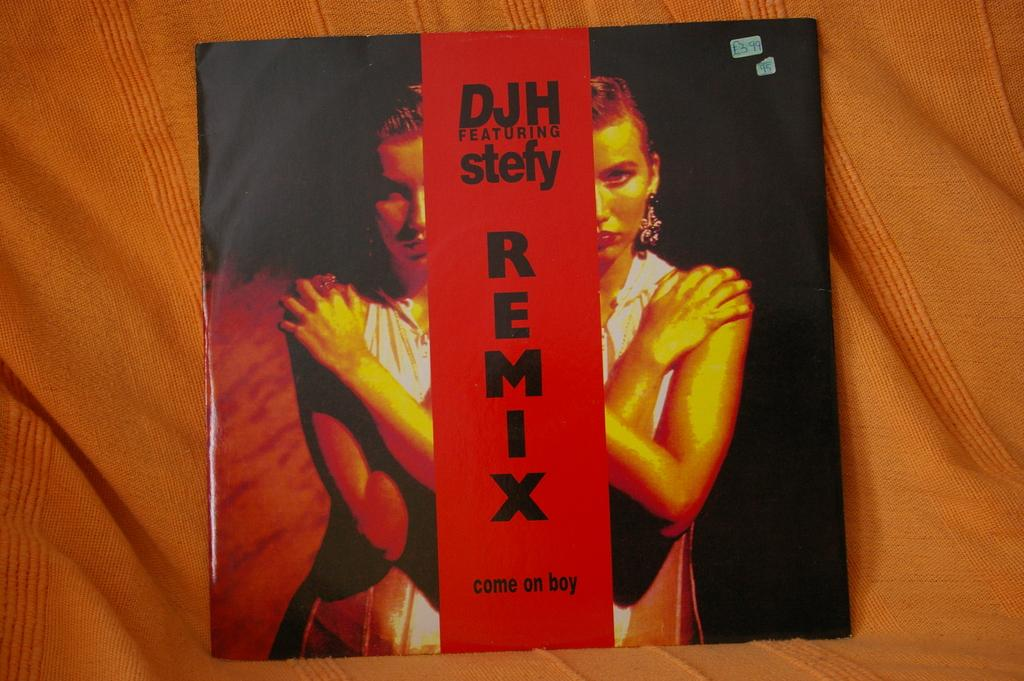<image>
Share a concise interpretation of the image provided. Cd cover for COme no boy by DJH featuring Stefy. 